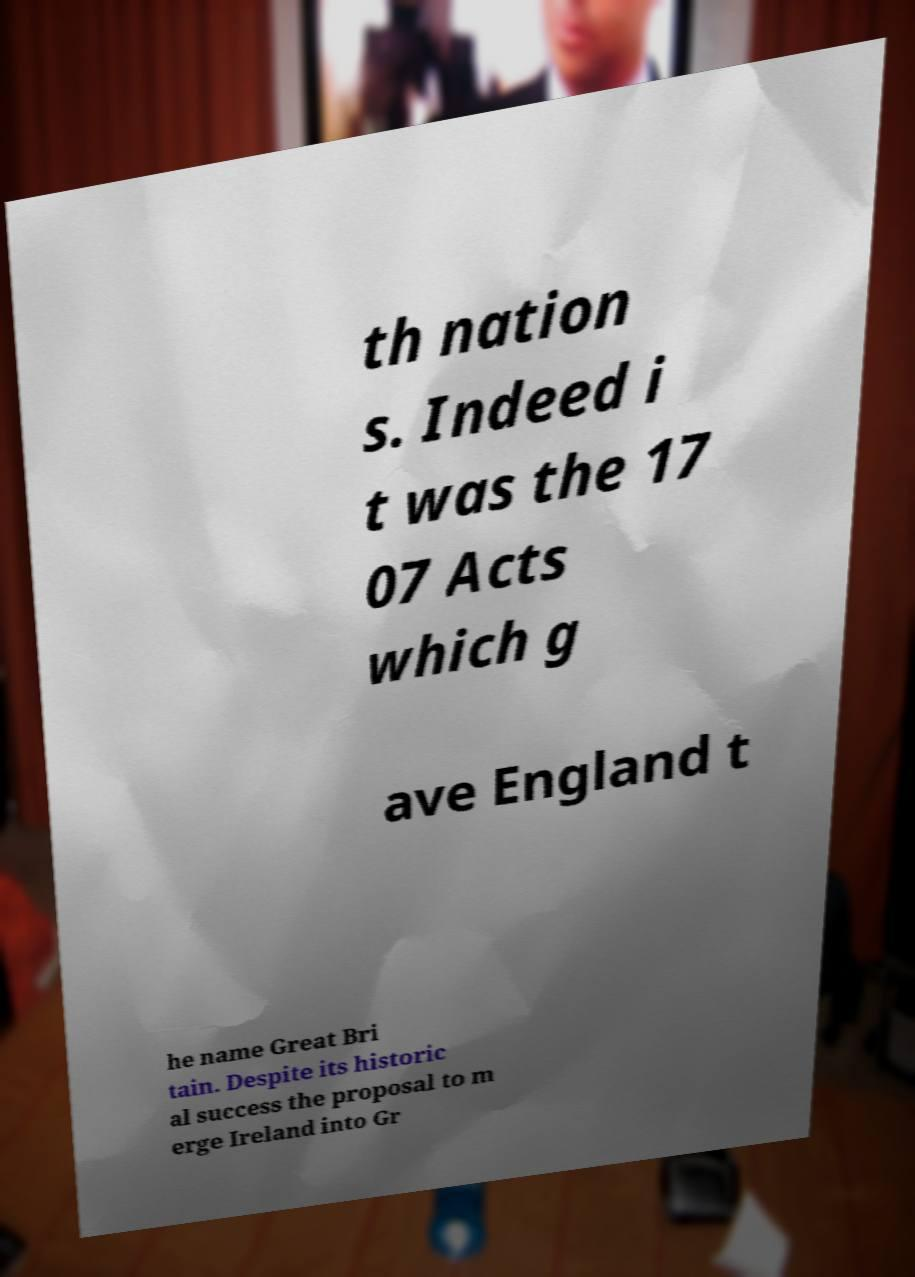Could you extract and type out the text from this image? th nation s. Indeed i t was the 17 07 Acts which g ave England t he name Great Bri tain. Despite its historic al success the proposal to m erge Ireland into Gr 